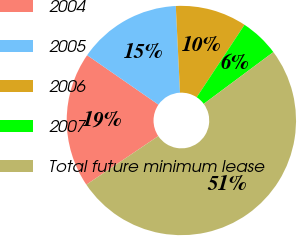Convert chart to OTSL. <chart><loc_0><loc_0><loc_500><loc_500><pie_chart><fcel>2004<fcel>2005<fcel>2006<fcel>2007<fcel>Total future minimum lease<nl><fcel>19.1%<fcel>14.58%<fcel>10.06%<fcel>5.54%<fcel>50.72%<nl></chart> 